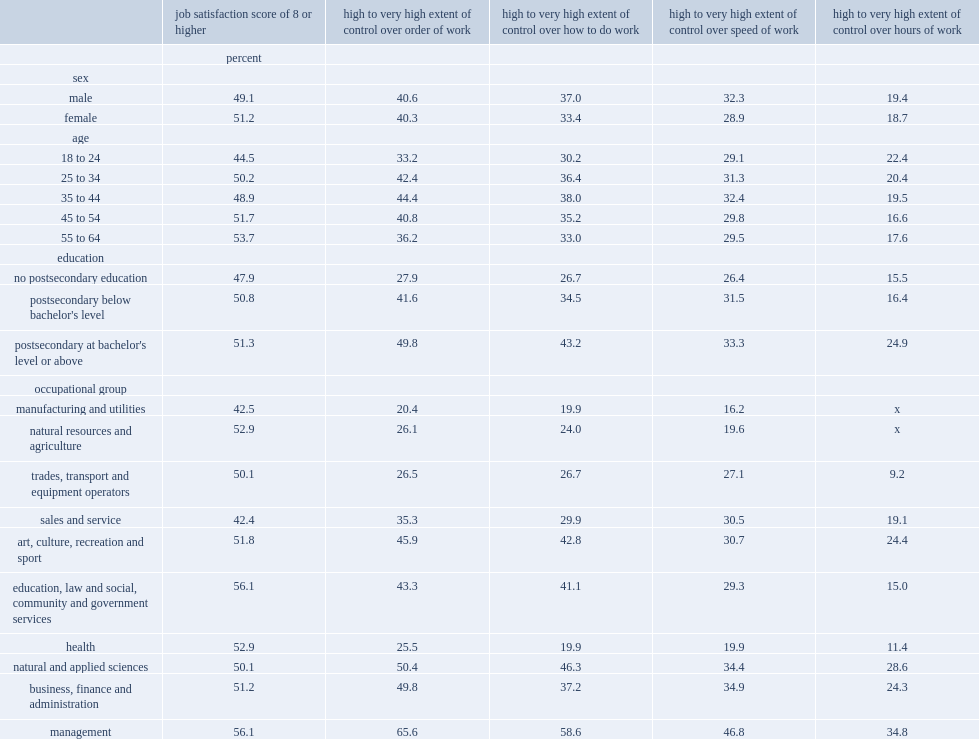Among all the age groups in 2014, which age group has the largest proportion of people who were satisfied with their job? 55 to 64. Which occupational group was less likely to be satisfied with their job? individuals working in service and manufacturing occupations or those working in management occupations? Manufacturing and utilities. How many percent of both men and women have reported a high to a very high extent of control over the order of work, respectively? 40.6 40.3. How many percent of both men and women reported a high or a very high extent of control over the hours of work, respectively? 19.4 18.7. Which group of people has a larger proportion of people reporting a high to a very high extent of control over how the work is done and the speed of work? men or women? Male. What proportion of individuals aged 18 to 24 and 55 to 64 respectively have reported a high to a very high extent of control over the order of work? 33.2 36.2. What is the range of the perentages of those with no postsecondary educationless more likely to report a high to a very high extent of control over a facet of job flexibility than those with a degree at the bachelor's level or above? 21.9 6.9. 